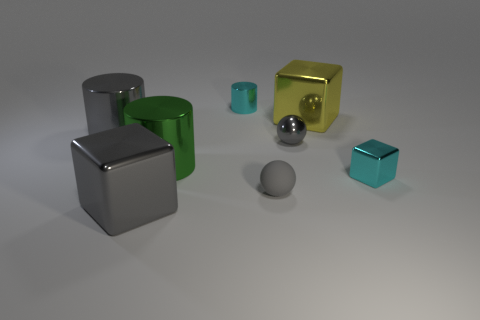Add 2 small matte spheres. How many objects exist? 10 Subtract all cubes. How many objects are left? 5 Add 5 big gray cubes. How many big gray cubes exist? 6 Subtract 1 green cylinders. How many objects are left? 7 Subtract all big shiny blocks. Subtract all big yellow metallic blocks. How many objects are left? 5 Add 3 metal blocks. How many metal blocks are left? 6 